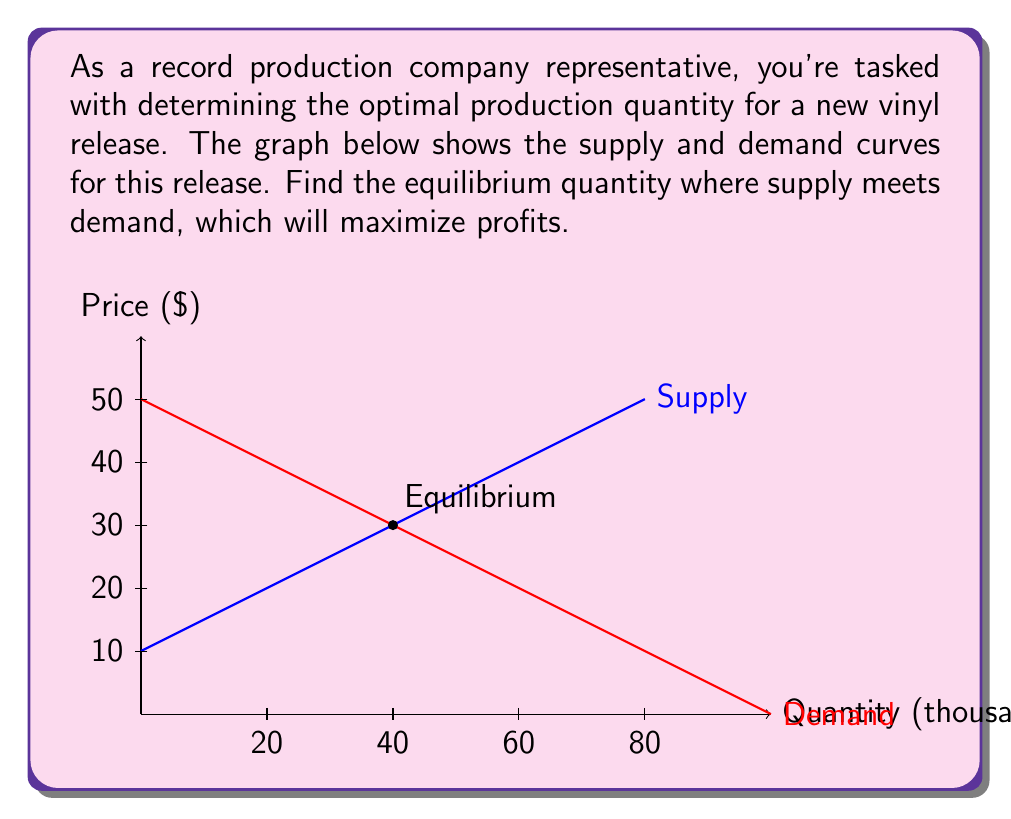Help me with this question. To find the equilibrium quantity, we need to determine where the supply and demand curves intersect. Let's approach this step-by-step:

1) From the graph, we can see that the supply curve is linear and increasing, while the demand curve is linear and decreasing.

2) The supply curve can be represented by the equation:
   $$P_s = 0.5Q + 10$$
   where $P_s$ is the supply price and $Q$ is the quantity.

3) The demand curve can be represented by the equation:
   $$P_d = -0.5Q + 50$$
   where $P_d$ is the demand price and $Q$ is the quantity.

4) At equilibrium, supply price equals demand price:
   $$P_s = P_d$$

5) Therefore, we can set up the equation:
   $$0.5Q + 10 = -0.5Q + 50$$

6) Solving for Q:
   $$0.5Q + 0.5Q = 50 - 10$$
   $$Q = 40$$

7) We can verify this by substituting Q = 40 into either the supply or demand equation:
   $$P = 0.5(40) + 10 = 30$$
   $$P = -0.5(40) + 50 = 30$$

Thus, the equilibrium quantity is 40,000 vinyl records, and the equilibrium price is $30.
Answer: 40,000 vinyl records 